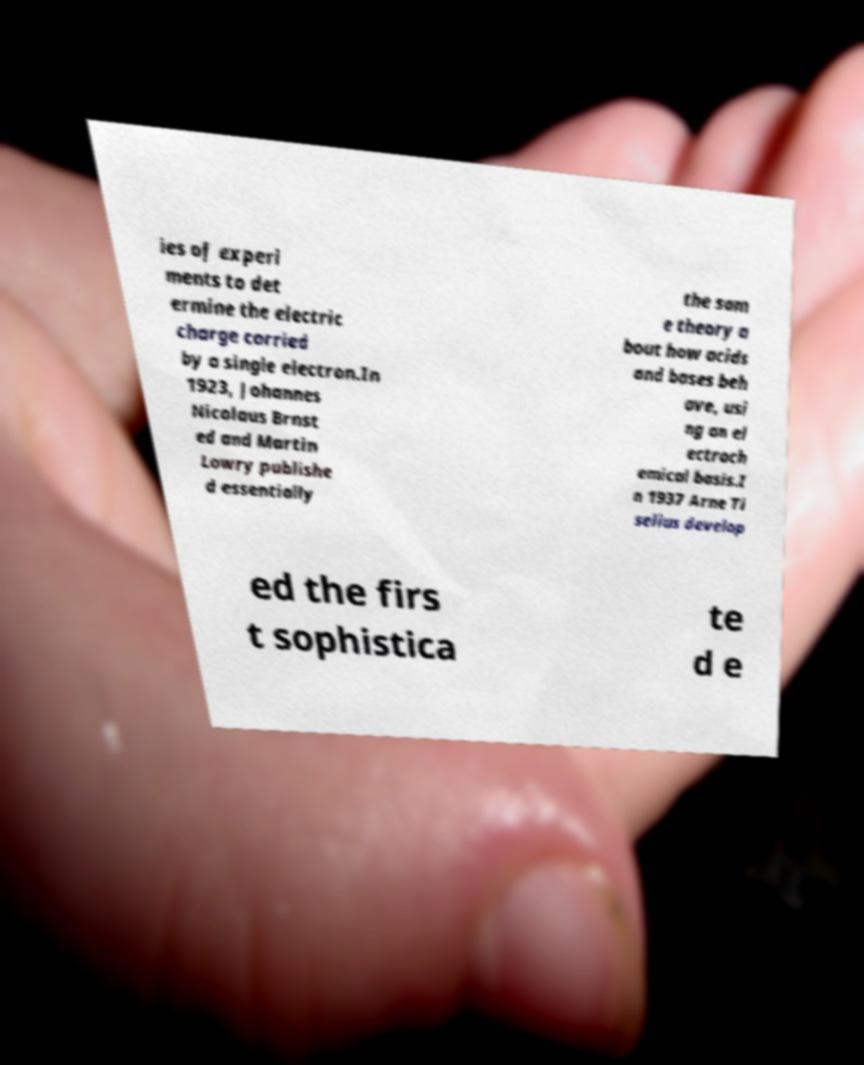I need the written content from this picture converted into text. Can you do that? ies of experi ments to det ermine the electric charge carried by a single electron.In 1923, Johannes Nicolaus Brnst ed and Martin Lowry publishe d essentially the sam e theory a bout how acids and bases beh ave, usi ng an el ectroch emical basis.I n 1937 Arne Ti selius develop ed the firs t sophistica te d e 